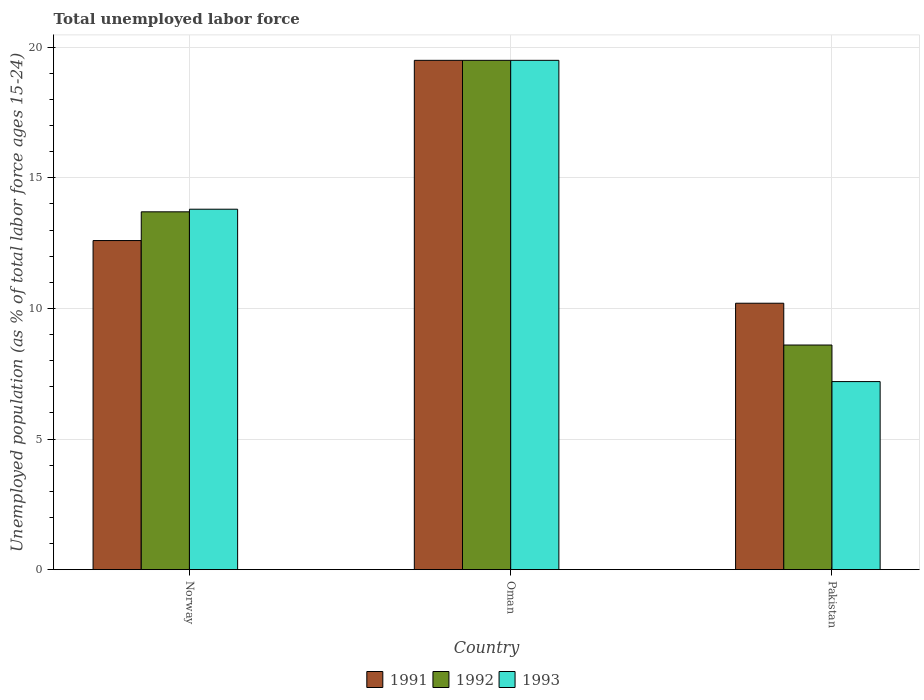How many different coloured bars are there?
Your response must be concise. 3. How many groups of bars are there?
Keep it short and to the point. 3. Are the number of bars per tick equal to the number of legend labels?
Your answer should be compact. Yes. How many bars are there on the 2nd tick from the left?
Your response must be concise. 3. How many bars are there on the 2nd tick from the right?
Provide a short and direct response. 3. What is the percentage of unemployed population in in 1991 in Norway?
Make the answer very short. 12.6. Across all countries, what is the minimum percentage of unemployed population in in 1993?
Ensure brevity in your answer.  7.2. In which country was the percentage of unemployed population in in 1991 maximum?
Keep it short and to the point. Oman. What is the total percentage of unemployed population in in 1992 in the graph?
Provide a short and direct response. 41.8. What is the difference between the percentage of unemployed population in in 1993 in Oman and that in Pakistan?
Ensure brevity in your answer.  12.3. What is the difference between the percentage of unemployed population in in 1992 in Norway and the percentage of unemployed population in in 1993 in Pakistan?
Keep it short and to the point. 6.5. What is the average percentage of unemployed population in in 1991 per country?
Give a very brief answer. 14.1. What is the difference between the percentage of unemployed population in of/in 1993 and percentage of unemployed population in of/in 1991 in Pakistan?
Your answer should be compact. -3. What is the ratio of the percentage of unemployed population in in 1993 in Oman to that in Pakistan?
Make the answer very short. 2.71. Is the difference between the percentage of unemployed population in in 1993 in Oman and Pakistan greater than the difference between the percentage of unemployed population in in 1991 in Oman and Pakistan?
Your response must be concise. Yes. What is the difference between the highest and the second highest percentage of unemployed population in in 1992?
Give a very brief answer. -10.9. What is the difference between the highest and the lowest percentage of unemployed population in in 1992?
Your answer should be very brief. 10.9. In how many countries, is the percentage of unemployed population in in 1991 greater than the average percentage of unemployed population in in 1991 taken over all countries?
Offer a terse response. 1. Is the sum of the percentage of unemployed population in in 1992 in Norway and Pakistan greater than the maximum percentage of unemployed population in in 1993 across all countries?
Give a very brief answer. Yes. What does the 1st bar from the left in Norway represents?
Give a very brief answer. 1991. Is it the case that in every country, the sum of the percentage of unemployed population in in 1991 and percentage of unemployed population in in 1992 is greater than the percentage of unemployed population in in 1993?
Offer a very short reply. Yes. How many bars are there?
Give a very brief answer. 9. How many countries are there in the graph?
Give a very brief answer. 3. Are the values on the major ticks of Y-axis written in scientific E-notation?
Your answer should be very brief. No. Where does the legend appear in the graph?
Offer a terse response. Bottom center. How many legend labels are there?
Give a very brief answer. 3. What is the title of the graph?
Make the answer very short. Total unemployed labor force. What is the label or title of the X-axis?
Ensure brevity in your answer.  Country. What is the label or title of the Y-axis?
Your answer should be compact. Unemployed population (as % of total labor force ages 15-24). What is the Unemployed population (as % of total labor force ages 15-24) in 1991 in Norway?
Give a very brief answer. 12.6. What is the Unemployed population (as % of total labor force ages 15-24) in 1992 in Norway?
Provide a succinct answer. 13.7. What is the Unemployed population (as % of total labor force ages 15-24) of 1993 in Norway?
Ensure brevity in your answer.  13.8. What is the Unemployed population (as % of total labor force ages 15-24) of 1992 in Oman?
Ensure brevity in your answer.  19.5. What is the Unemployed population (as % of total labor force ages 15-24) of 1991 in Pakistan?
Your answer should be very brief. 10.2. What is the Unemployed population (as % of total labor force ages 15-24) of 1992 in Pakistan?
Provide a succinct answer. 8.6. What is the Unemployed population (as % of total labor force ages 15-24) in 1993 in Pakistan?
Provide a succinct answer. 7.2. Across all countries, what is the minimum Unemployed population (as % of total labor force ages 15-24) in 1991?
Provide a short and direct response. 10.2. Across all countries, what is the minimum Unemployed population (as % of total labor force ages 15-24) of 1992?
Ensure brevity in your answer.  8.6. Across all countries, what is the minimum Unemployed population (as % of total labor force ages 15-24) in 1993?
Your answer should be compact. 7.2. What is the total Unemployed population (as % of total labor force ages 15-24) of 1991 in the graph?
Provide a short and direct response. 42.3. What is the total Unemployed population (as % of total labor force ages 15-24) in 1992 in the graph?
Provide a succinct answer. 41.8. What is the total Unemployed population (as % of total labor force ages 15-24) in 1993 in the graph?
Offer a terse response. 40.5. What is the difference between the Unemployed population (as % of total labor force ages 15-24) in 1993 in Norway and that in Oman?
Give a very brief answer. -5.7. What is the difference between the Unemployed population (as % of total labor force ages 15-24) of 1991 in Norway and that in Pakistan?
Provide a succinct answer. 2.4. What is the difference between the Unemployed population (as % of total labor force ages 15-24) in 1991 in Oman and that in Pakistan?
Offer a terse response. 9.3. What is the difference between the Unemployed population (as % of total labor force ages 15-24) in 1991 in Norway and the Unemployed population (as % of total labor force ages 15-24) in 1993 in Oman?
Make the answer very short. -6.9. What is the difference between the Unemployed population (as % of total labor force ages 15-24) of 1992 in Norway and the Unemployed population (as % of total labor force ages 15-24) of 1993 in Oman?
Your response must be concise. -5.8. What is the difference between the Unemployed population (as % of total labor force ages 15-24) of 1991 in Norway and the Unemployed population (as % of total labor force ages 15-24) of 1993 in Pakistan?
Provide a short and direct response. 5.4. What is the difference between the Unemployed population (as % of total labor force ages 15-24) of 1992 in Norway and the Unemployed population (as % of total labor force ages 15-24) of 1993 in Pakistan?
Give a very brief answer. 6.5. What is the difference between the Unemployed population (as % of total labor force ages 15-24) of 1991 in Oman and the Unemployed population (as % of total labor force ages 15-24) of 1992 in Pakistan?
Ensure brevity in your answer.  10.9. What is the average Unemployed population (as % of total labor force ages 15-24) of 1992 per country?
Give a very brief answer. 13.93. What is the average Unemployed population (as % of total labor force ages 15-24) in 1993 per country?
Your answer should be very brief. 13.5. What is the difference between the Unemployed population (as % of total labor force ages 15-24) in 1991 and Unemployed population (as % of total labor force ages 15-24) in 1992 in Oman?
Your answer should be compact. 0. What is the difference between the Unemployed population (as % of total labor force ages 15-24) in 1991 and Unemployed population (as % of total labor force ages 15-24) in 1993 in Oman?
Offer a terse response. 0. What is the difference between the Unemployed population (as % of total labor force ages 15-24) of 1991 and Unemployed population (as % of total labor force ages 15-24) of 1993 in Pakistan?
Provide a short and direct response. 3. What is the difference between the Unemployed population (as % of total labor force ages 15-24) in 1992 and Unemployed population (as % of total labor force ages 15-24) in 1993 in Pakistan?
Your answer should be compact. 1.4. What is the ratio of the Unemployed population (as % of total labor force ages 15-24) of 1991 in Norway to that in Oman?
Make the answer very short. 0.65. What is the ratio of the Unemployed population (as % of total labor force ages 15-24) of 1992 in Norway to that in Oman?
Ensure brevity in your answer.  0.7. What is the ratio of the Unemployed population (as % of total labor force ages 15-24) of 1993 in Norway to that in Oman?
Provide a succinct answer. 0.71. What is the ratio of the Unemployed population (as % of total labor force ages 15-24) in 1991 in Norway to that in Pakistan?
Keep it short and to the point. 1.24. What is the ratio of the Unemployed population (as % of total labor force ages 15-24) in 1992 in Norway to that in Pakistan?
Your response must be concise. 1.59. What is the ratio of the Unemployed population (as % of total labor force ages 15-24) in 1993 in Norway to that in Pakistan?
Offer a terse response. 1.92. What is the ratio of the Unemployed population (as % of total labor force ages 15-24) of 1991 in Oman to that in Pakistan?
Your answer should be compact. 1.91. What is the ratio of the Unemployed population (as % of total labor force ages 15-24) of 1992 in Oman to that in Pakistan?
Provide a succinct answer. 2.27. What is the ratio of the Unemployed population (as % of total labor force ages 15-24) in 1993 in Oman to that in Pakistan?
Offer a terse response. 2.71. What is the difference between the highest and the second highest Unemployed population (as % of total labor force ages 15-24) in 1992?
Keep it short and to the point. 5.8. What is the difference between the highest and the second highest Unemployed population (as % of total labor force ages 15-24) of 1993?
Your answer should be very brief. 5.7. What is the difference between the highest and the lowest Unemployed population (as % of total labor force ages 15-24) of 1992?
Keep it short and to the point. 10.9. 